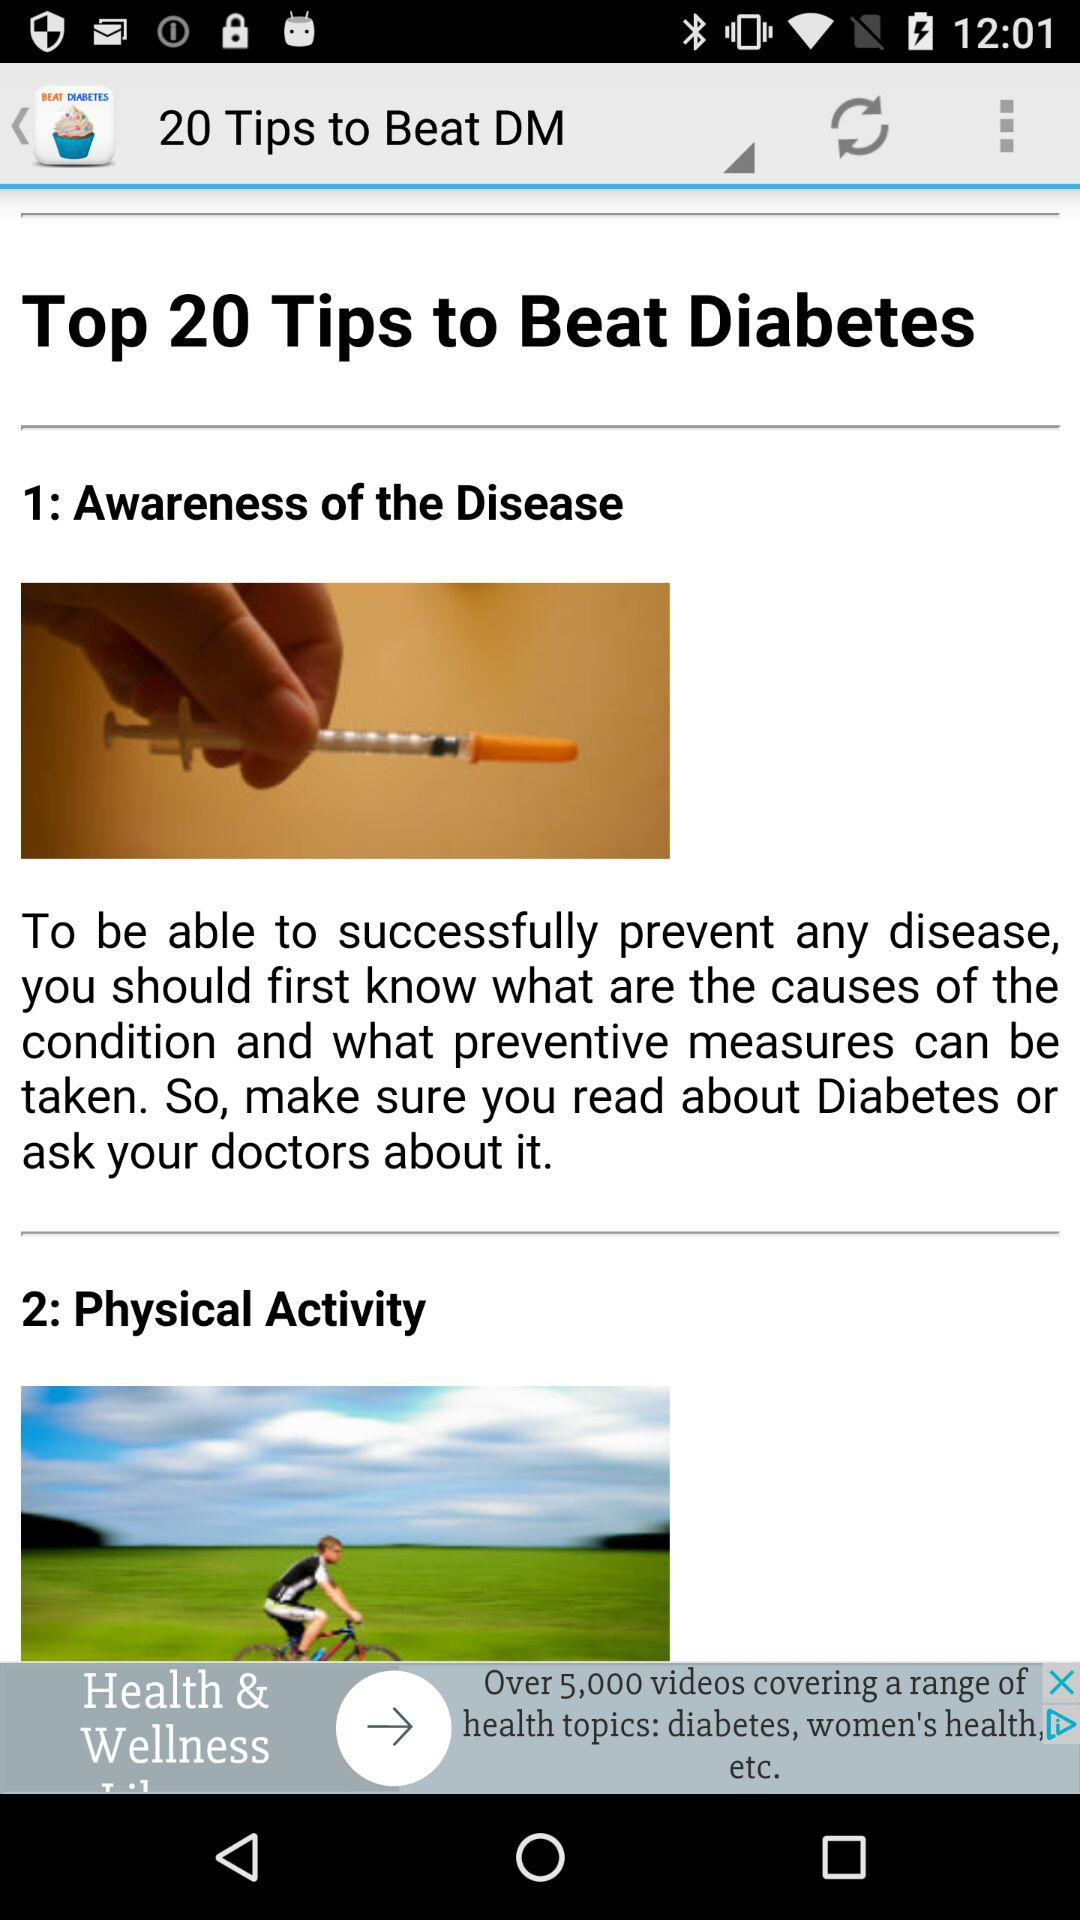How many tips are there in total?
Answer the question using a single word or phrase. 20 